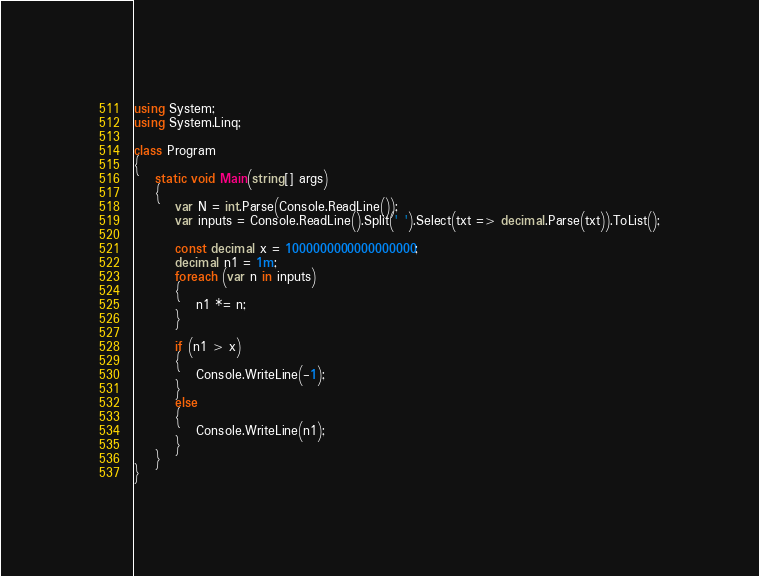<code> <loc_0><loc_0><loc_500><loc_500><_C#_>using System;
using System.Linq;

class Program
{
    static void Main(string[] args)
    {
        var N = int.Parse(Console.ReadLine());
        var inputs = Console.ReadLine().Split(' ').Select(txt => decimal.Parse(txt)).ToList();

        const decimal x = 1000000000000000000;
        decimal n1 = 1m;
        foreach (var n in inputs)
        {
            n1 *= n;
        }

        if (n1 > x)
        {
            Console.WriteLine(-1);
        }
        else
        {
            Console.WriteLine(n1);
        }
    }
}</code> 